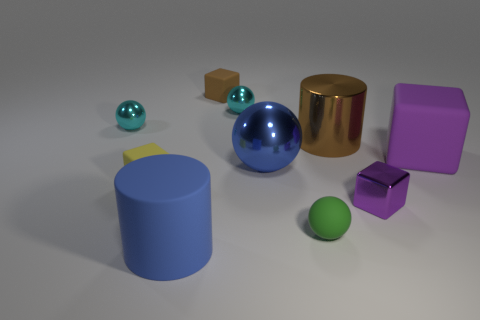Subtract all brown cylinders. How many cyan spheres are left? 2 Subtract all matte blocks. How many blocks are left? 1 Subtract 1 cylinders. How many cylinders are left? 1 Subtract all brown cubes. How many cubes are left? 3 Subtract all cylinders. How many objects are left? 8 Subtract all blue cylinders. Subtract all purple cubes. How many cylinders are left? 1 Subtract all small purple things. Subtract all big blue metal spheres. How many objects are left? 8 Add 1 metallic things. How many metallic things are left? 6 Add 5 tiny blue blocks. How many tiny blue blocks exist? 5 Subtract 0 gray cylinders. How many objects are left? 10 